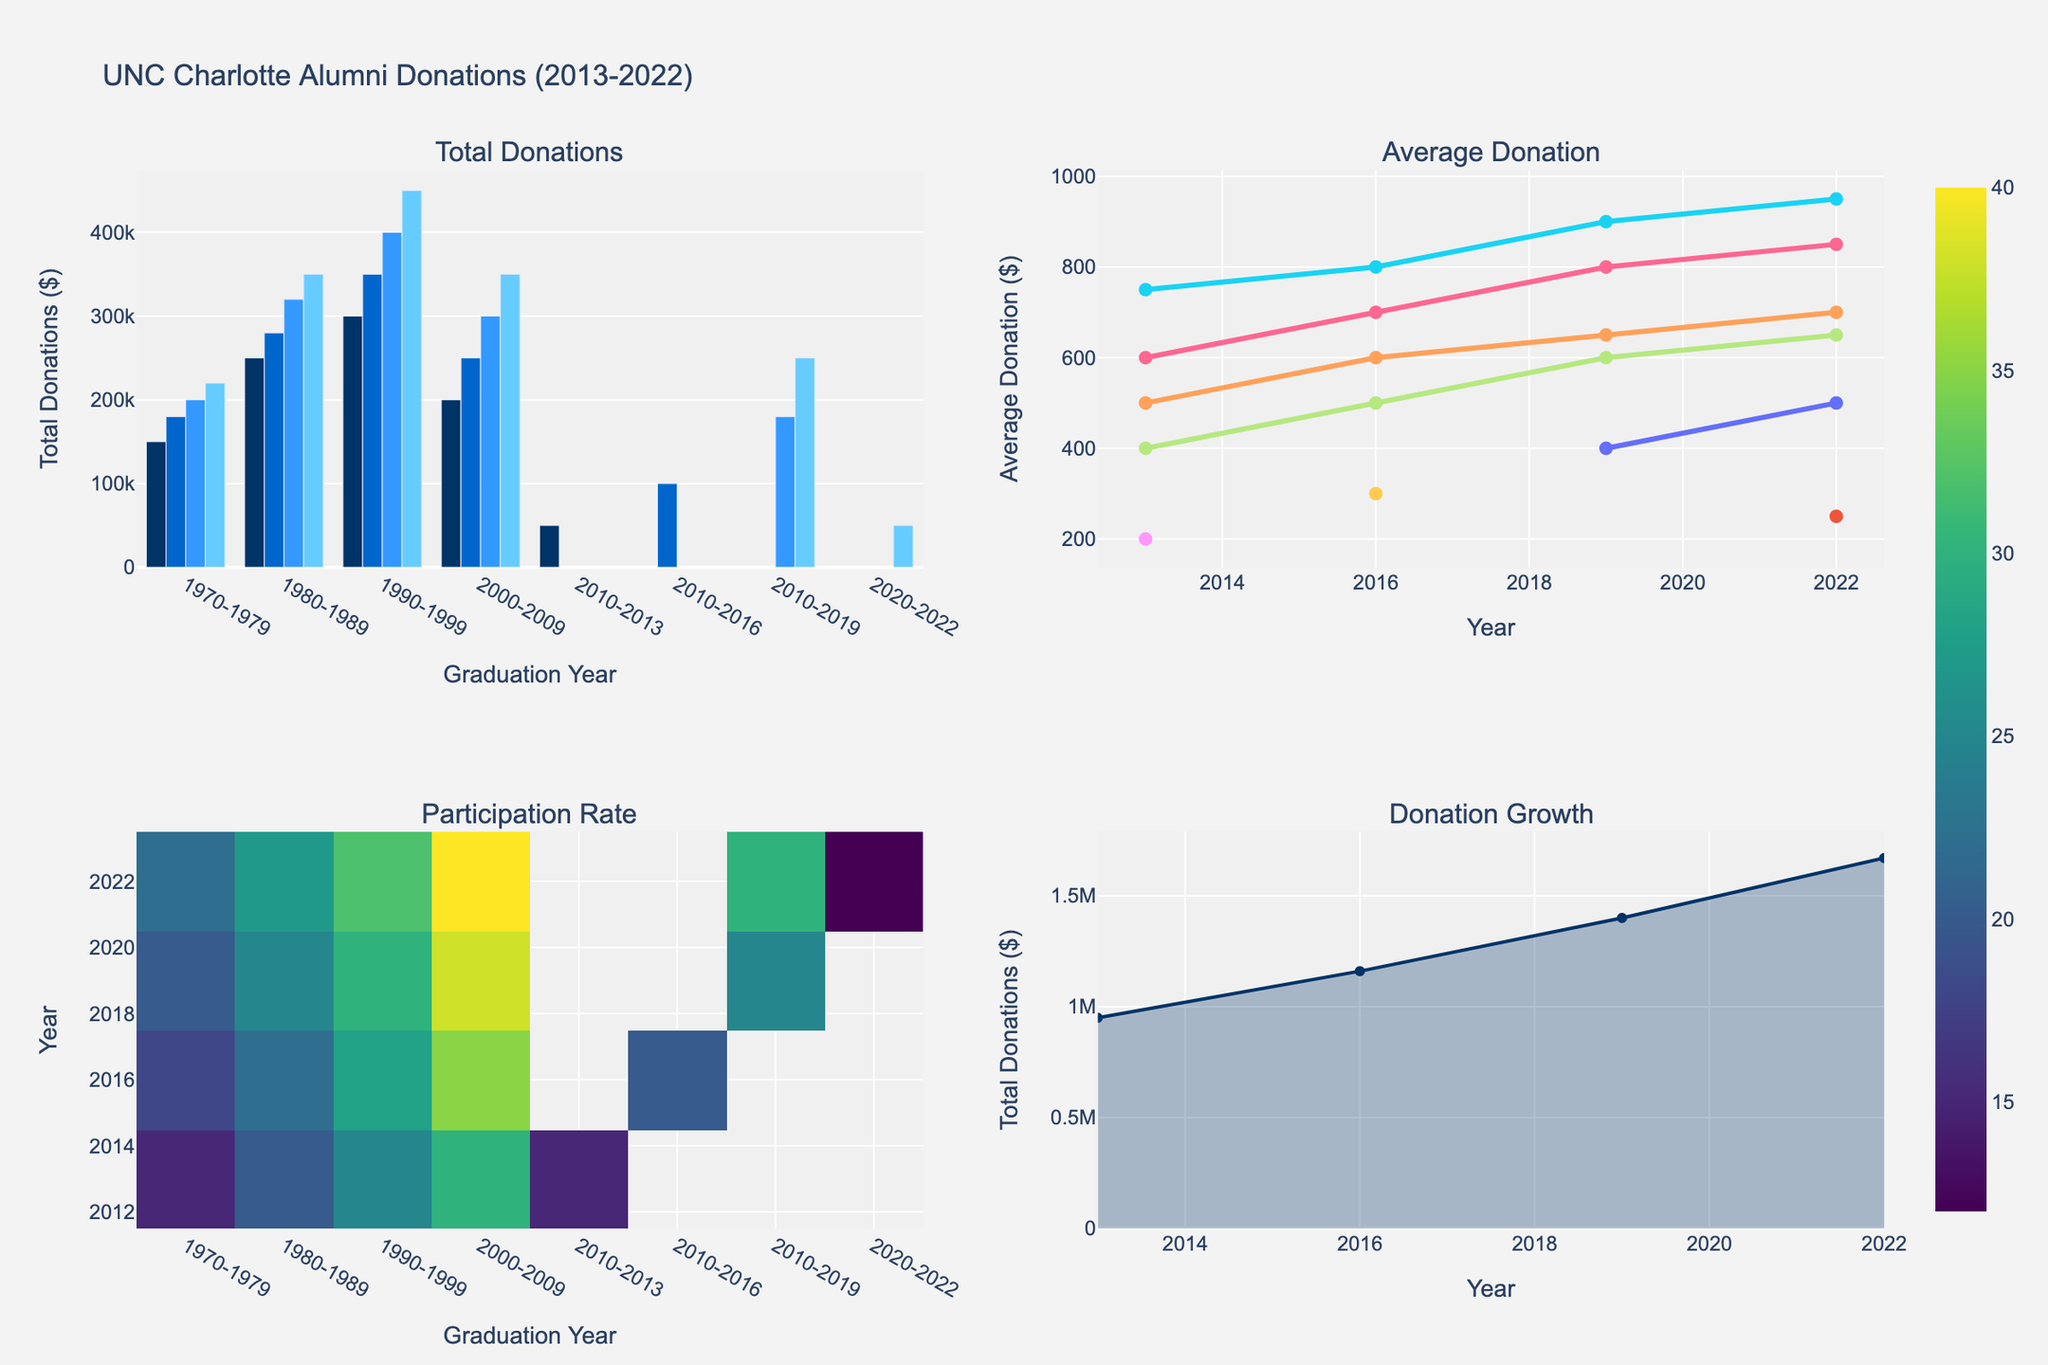Which year had the highest total donations for the 1990-1999 graduation cohort? Look at the bar chart in the Total Donations subplot. Identify the year where the bar representing the 1990-1999 cohort is the tallest.
Answer: 2022 What is the average donation trend for the 1980-1989 cohort? Check the line chart in the Average Donation subplot. Follow the line representing the 1980-1989 cohort from left to right to see if it increases, decreases, or remains constant.
Answer: Increasing How does the participation rate for the 2010-2019 cohort change over the years? Look at the heatmap in the Participation Rate subplot. Follow the row corresponding to the 2010-2019 cohort from left to right and observe the changes in color intensity.
Answer: Increasing Which cohort had the lowest average donation in 2022? Refer to the line chart in the Average Donation subplot and look at the data points for the year 2022. Identify the lowest data point.
Answer: 2020-2022 Compare the total donations between 2016 and 2022 for the 2000-2009 cohort. Look at the bar chart in the Total Donations subplot. Locate the bars for the 2000-2009 cohort in 2016 and 2022, and compare their heights.
Answer: Higher in 2022 What is the participation rate trend for the 1970-1979 cohort? Refer to the heatmap in the Participation Rate subplot. Follow the row corresponding to the 1970-1979 cohort from left to right and observe the color changes.
Answer: Increasing Which cohort has the most fluctuating average donation trends? Check the line chart in the Average Donation subplot. Look for the line with the most ups and downs.
Answer: 2010-2019 In which year did the total donations see the most substantial increase? Look at the area chart in the Donation Growth subplot. Identify the year with the steepest increase in the area under the curve.
Answer: 2019 How did the participation rate of the 2000-2009 cohort change from 2019 to 2022? Look at the heatmap in the Participation Rate subplot. Compare the colors for the 2000-2009 cohort from 2019 to 2022.
Answer: Increased Which cohort consistently had the highest participation rate? Refer to the heatmap in the Participation Rate subplot. Identify which row consistently has the darkest color, indicating the highest rate.
Answer: 2000-2009 